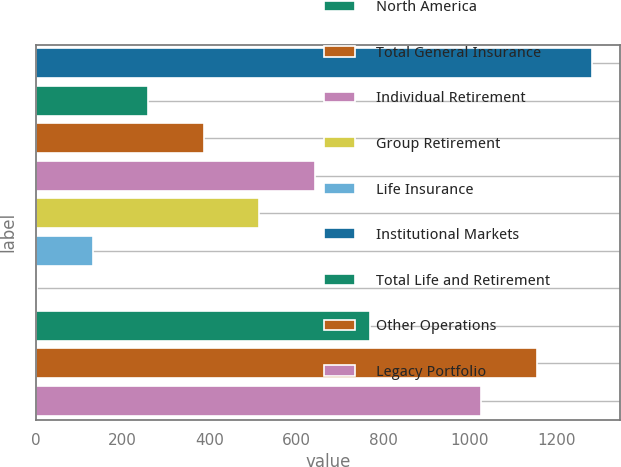Convert chart to OTSL. <chart><loc_0><loc_0><loc_500><loc_500><bar_chart><fcel>Revenues and Pre-tax income<fcel>North America<fcel>Total General Insurance<fcel>Individual Retirement<fcel>Group Retirement<fcel>Life Insurance<fcel>Institutional Markets<fcel>Total Life and Retirement<fcel>Other Operations<fcel>Legacy Portfolio<nl><fcel>1281<fcel>258.6<fcel>386.4<fcel>642<fcel>514.2<fcel>130.8<fcel>3<fcel>769.8<fcel>1153.2<fcel>1025.4<nl></chart> 